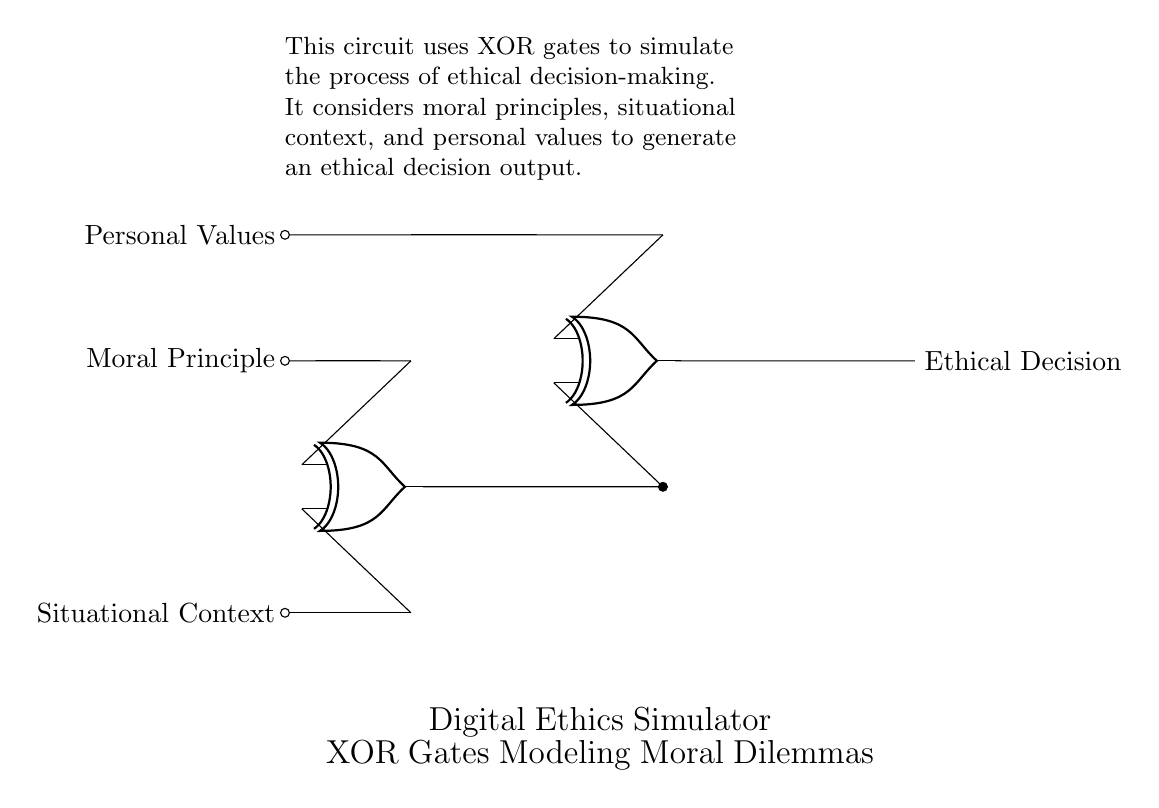What are the inputs of the circuit? The inputs are "Moral Principle," "Situational Context," and "Personal Values," which are all labeled on the left side of the circuit diagram and connected to their respective points.
Answer: Moral Principle, Situational Context, Personal Values How many XOR gates are in this circuit? There are two XOR gates in the circuit, as shown by the two 'xor port' symbols located at different points in the circuit diagram.
Answer: 2 What is the output of the circuit? The output of the circuit is labeled as "Ethical Decision," which is found at the end of the circuit diagram.
Answer: Ethical Decision If 'Moral Principle' is true and 'Situational Context' is false, what will the output be? The first XOR gate evaluates 'true' and 'false' which results in 'true' (1). This output is fed into the second XOR gate along with 'Personal Values.' Depending on the nature of 'Personal Values', it will either remain true or change. Therefore, without knowing 'Personal Values,' we cannot determine the exact final output.
Answer: Depends on Personal Values What does an XOR gate do? An XOR gate outputs true only when the number of true inputs is odd. In this circuit, each XOR evaluates the inputs it receives, modeling the decision-making process depending on moral principles, situational context, and personal values.
Answer: Outputs true when inputs differ How does the circuit simulate ethical decision-making? The circuit uses the XOR gates to compare the different inputs, representing moral principles, situational context, and personal values. The outcome reflects the dynamic interaction between these factors, allowing the simulation of various moral dilemmas through their combinations.
Answer: By comparing inputs What is the function of the intermediate node in the circuit? The intermediate node connects the output of the first XOR gate to the second XOR gate. It serves as a transition point for the output value to enter the next stage in the decision-making process.
Answer: To connect the output of the first XOR gate to the second 